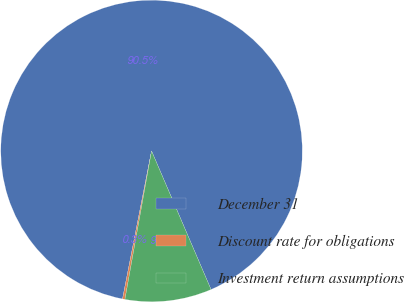<chart> <loc_0><loc_0><loc_500><loc_500><pie_chart><fcel>December 31<fcel>Discount rate for obligations<fcel>Investment return assumptions<nl><fcel>90.46%<fcel>0.26%<fcel>9.28%<nl></chart> 